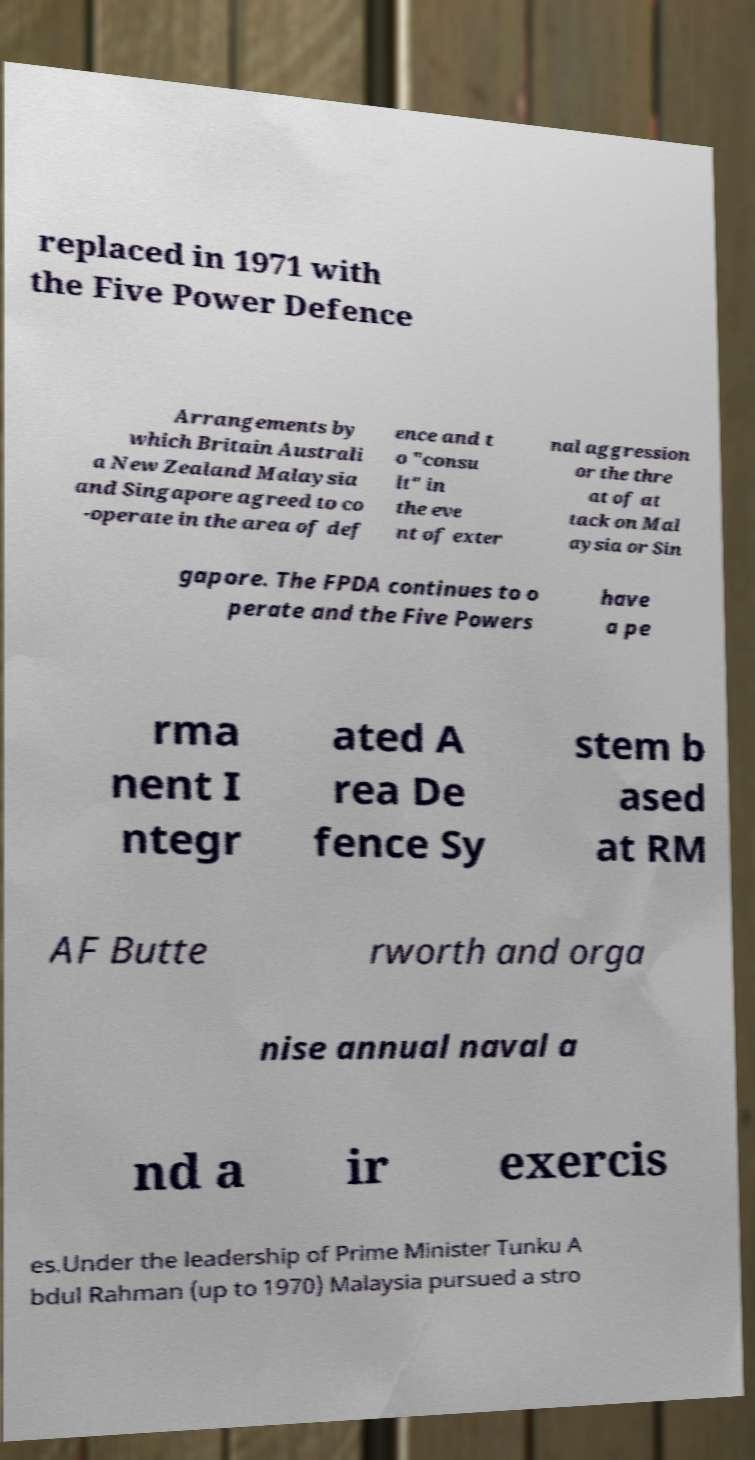Please read and relay the text visible in this image. What does it say? replaced in 1971 with the Five Power Defence Arrangements by which Britain Australi a New Zealand Malaysia and Singapore agreed to co -operate in the area of def ence and t o "consu lt" in the eve nt of exter nal aggression or the thre at of at tack on Mal aysia or Sin gapore. The FPDA continues to o perate and the Five Powers have a pe rma nent I ntegr ated A rea De fence Sy stem b ased at RM AF Butte rworth and orga nise annual naval a nd a ir exercis es.Under the leadership of Prime Minister Tunku A bdul Rahman (up to 1970) Malaysia pursued a stro 